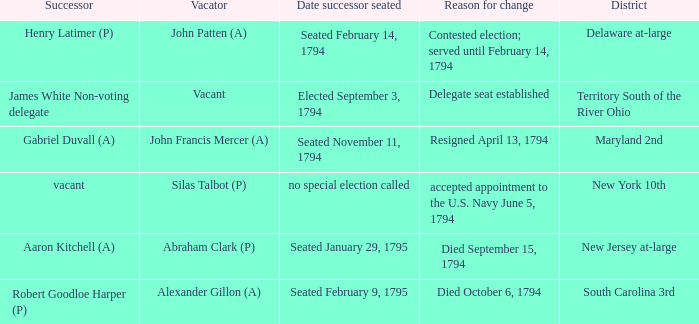Name the date successor seated for contested election; served until february 14, 1794 Seated February 14, 1794. 